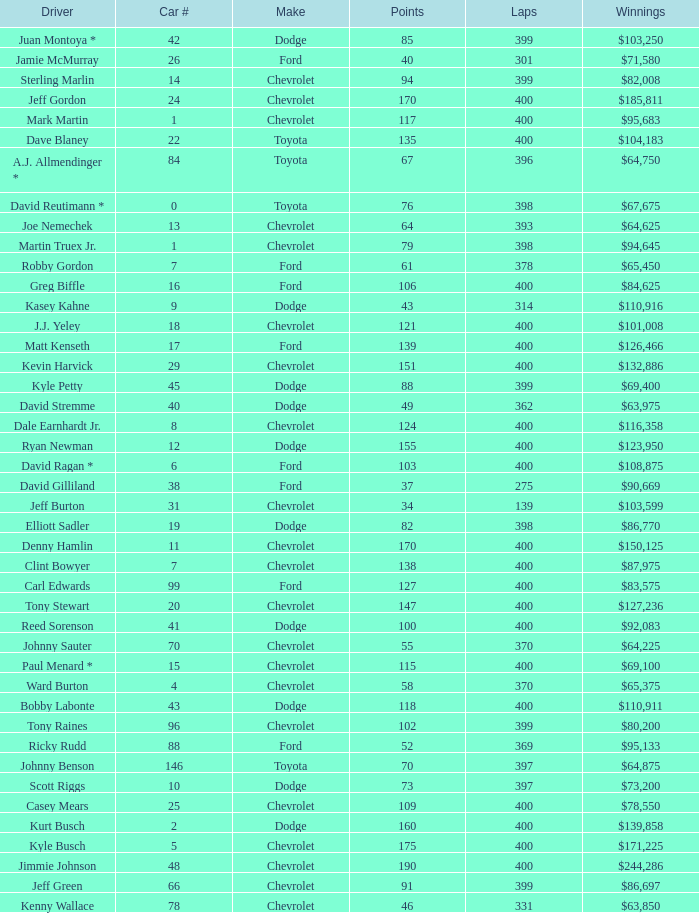What is the car number that has less than 369 laps for a Dodge with more than 49 points? None. 